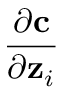<formula> <loc_0><loc_0><loc_500><loc_500>\frac { \partial c } { \partial z _ { i } }</formula> 